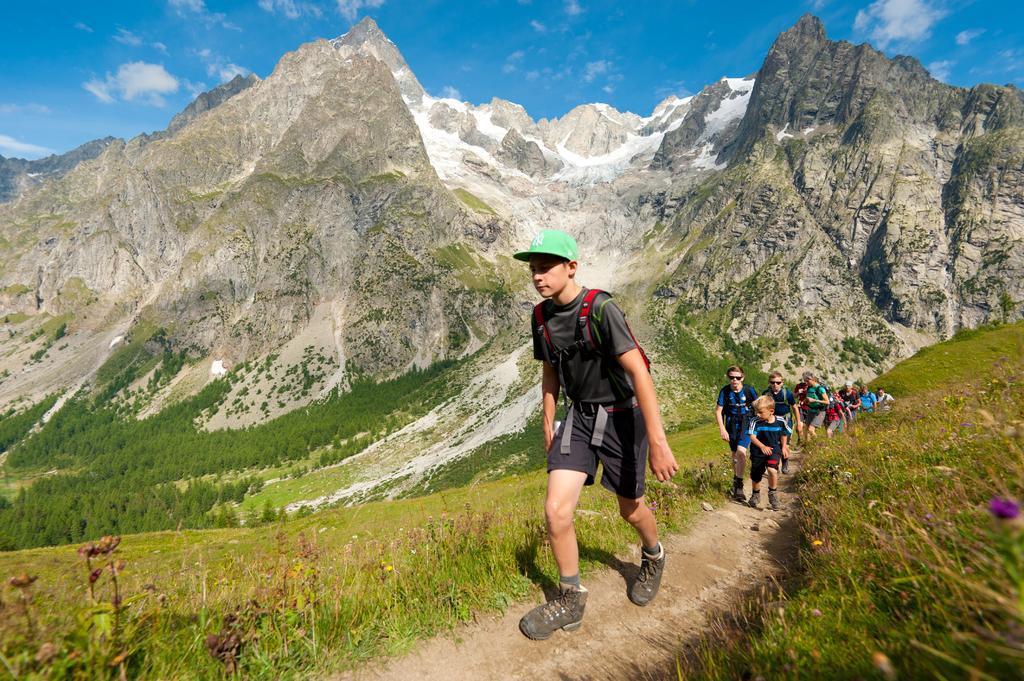Describe this image in one or two sentences. In this picture there is a boy wearing black t-shirt and shorts is climbing the mountain. Behind there is a group of boys climbing the hill. In the background we can see a beautiful scene of mountains and trees. 